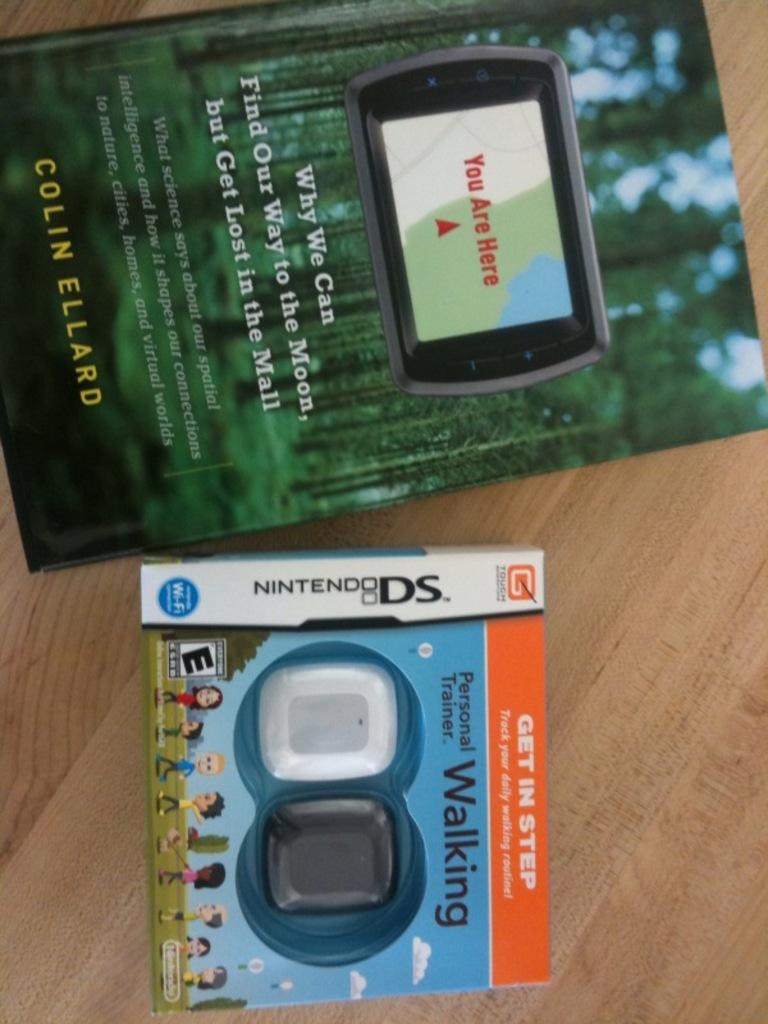Is this a nintendo ds game?
Your answer should be very brief. Yes. Who wrote the book pictured here?
Provide a short and direct response. Colin ellard. 